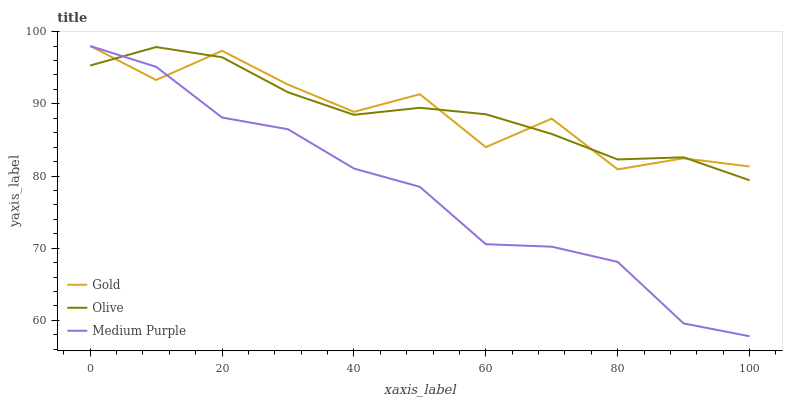Does Medium Purple have the minimum area under the curve?
Answer yes or no. Yes. Does Olive have the maximum area under the curve?
Answer yes or no. Yes. Does Gold have the minimum area under the curve?
Answer yes or no. No. Does Gold have the maximum area under the curve?
Answer yes or no. No. Is Olive the smoothest?
Answer yes or no. Yes. Is Gold the roughest?
Answer yes or no. Yes. Is Medium Purple the smoothest?
Answer yes or no. No. Is Medium Purple the roughest?
Answer yes or no. No. Does Medium Purple have the lowest value?
Answer yes or no. Yes. Does Gold have the lowest value?
Answer yes or no. No. Does Gold have the highest value?
Answer yes or no. Yes. Does Gold intersect Medium Purple?
Answer yes or no. Yes. Is Gold less than Medium Purple?
Answer yes or no. No. Is Gold greater than Medium Purple?
Answer yes or no. No. 